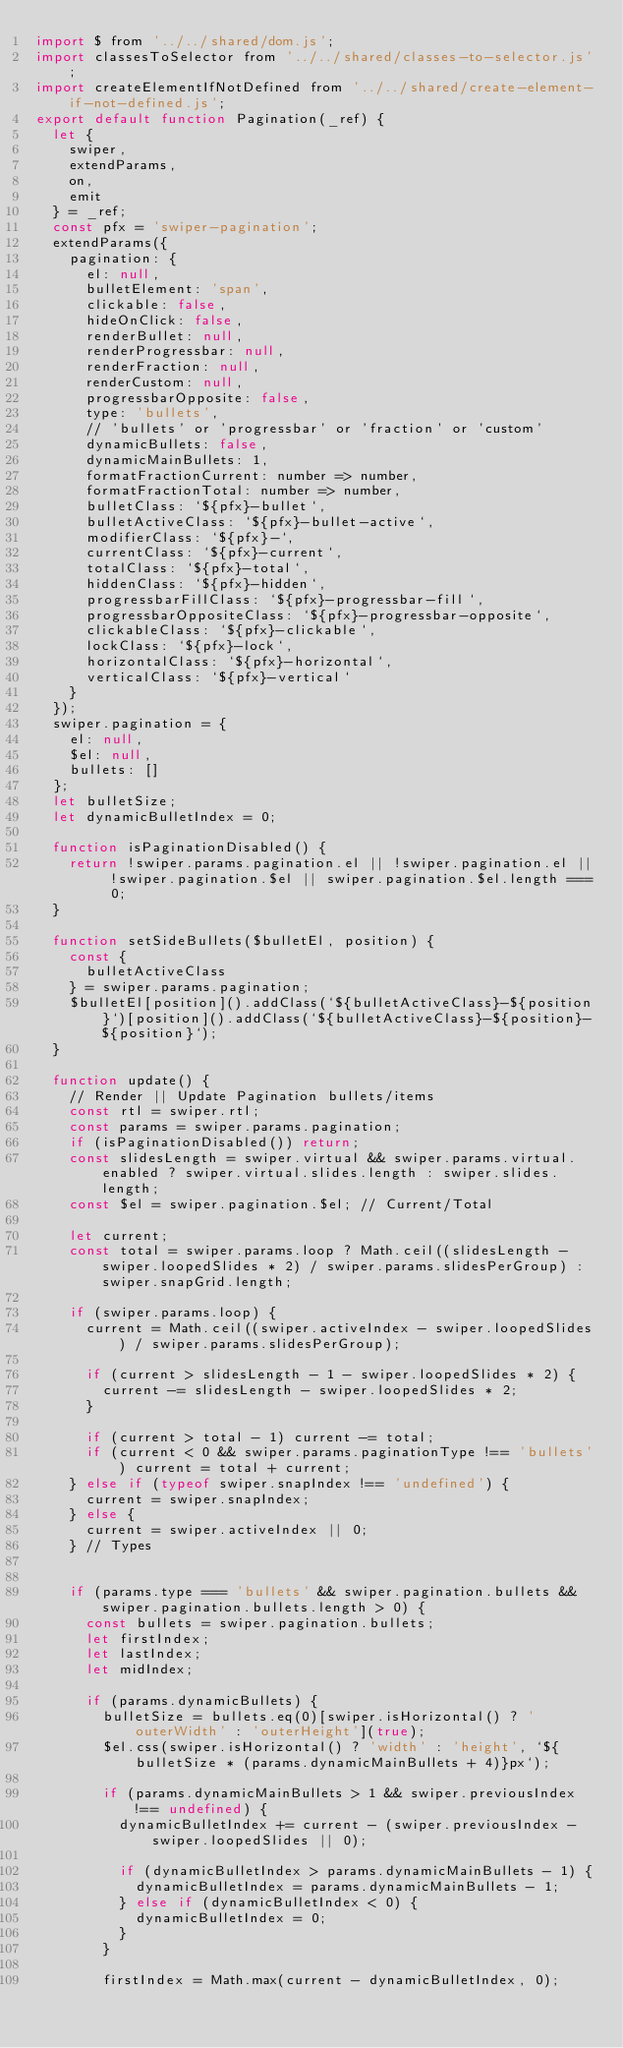Convert code to text. <code><loc_0><loc_0><loc_500><loc_500><_JavaScript_>import $ from '../../shared/dom.js';
import classesToSelector from '../../shared/classes-to-selector.js';
import createElementIfNotDefined from '../../shared/create-element-if-not-defined.js';
export default function Pagination(_ref) {
  let {
    swiper,
    extendParams,
    on,
    emit
  } = _ref;
  const pfx = 'swiper-pagination';
  extendParams({
    pagination: {
      el: null,
      bulletElement: 'span',
      clickable: false,
      hideOnClick: false,
      renderBullet: null,
      renderProgressbar: null,
      renderFraction: null,
      renderCustom: null,
      progressbarOpposite: false,
      type: 'bullets',
      // 'bullets' or 'progressbar' or 'fraction' or 'custom'
      dynamicBullets: false,
      dynamicMainBullets: 1,
      formatFractionCurrent: number => number,
      formatFractionTotal: number => number,
      bulletClass: `${pfx}-bullet`,
      bulletActiveClass: `${pfx}-bullet-active`,
      modifierClass: `${pfx}-`,
      currentClass: `${pfx}-current`,
      totalClass: `${pfx}-total`,
      hiddenClass: `${pfx}-hidden`,
      progressbarFillClass: `${pfx}-progressbar-fill`,
      progressbarOppositeClass: `${pfx}-progressbar-opposite`,
      clickableClass: `${pfx}-clickable`,
      lockClass: `${pfx}-lock`,
      horizontalClass: `${pfx}-horizontal`,
      verticalClass: `${pfx}-vertical`
    }
  });
  swiper.pagination = {
    el: null,
    $el: null,
    bullets: []
  };
  let bulletSize;
  let dynamicBulletIndex = 0;

  function isPaginationDisabled() {
    return !swiper.params.pagination.el || !swiper.pagination.el || !swiper.pagination.$el || swiper.pagination.$el.length === 0;
  }

  function setSideBullets($bulletEl, position) {
    const {
      bulletActiveClass
    } = swiper.params.pagination;
    $bulletEl[position]().addClass(`${bulletActiveClass}-${position}`)[position]().addClass(`${bulletActiveClass}-${position}-${position}`);
  }

  function update() {
    // Render || Update Pagination bullets/items
    const rtl = swiper.rtl;
    const params = swiper.params.pagination;
    if (isPaginationDisabled()) return;
    const slidesLength = swiper.virtual && swiper.params.virtual.enabled ? swiper.virtual.slides.length : swiper.slides.length;
    const $el = swiper.pagination.$el; // Current/Total

    let current;
    const total = swiper.params.loop ? Math.ceil((slidesLength - swiper.loopedSlides * 2) / swiper.params.slidesPerGroup) : swiper.snapGrid.length;

    if (swiper.params.loop) {
      current = Math.ceil((swiper.activeIndex - swiper.loopedSlides) / swiper.params.slidesPerGroup);

      if (current > slidesLength - 1 - swiper.loopedSlides * 2) {
        current -= slidesLength - swiper.loopedSlides * 2;
      }

      if (current > total - 1) current -= total;
      if (current < 0 && swiper.params.paginationType !== 'bullets') current = total + current;
    } else if (typeof swiper.snapIndex !== 'undefined') {
      current = swiper.snapIndex;
    } else {
      current = swiper.activeIndex || 0;
    } // Types


    if (params.type === 'bullets' && swiper.pagination.bullets && swiper.pagination.bullets.length > 0) {
      const bullets = swiper.pagination.bullets;
      let firstIndex;
      let lastIndex;
      let midIndex;

      if (params.dynamicBullets) {
        bulletSize = bullets.eq(0)[swiper.isHorizontal() ? 'outerWidth' : 'outerHeight'](true);
        $el.css(swiper.isHorizontal() ? 'width' : 'height', `${bulletSize * (params.dynamicMainBullets + 4)}px`);

        if (params.dynamicMainBullets > 1 && swiper.previousIndex !== undefined) {
          dynamicBulletIndex += current - (swiper.previousIndex - swiper.loopedSlides || 0);

          if (dynamicBulletIndex > params.dynamicMainBullets - 1) {
            dynamicBulletIndex = params.dynamicMainBullets - 1;
          } else if (dynamicBulletIndex < 0) {
            dynamicBulletIndex = 0;
          }
        }

        firstIndex = Math.max(current - dynamicBulletIndex, 0);</code> 